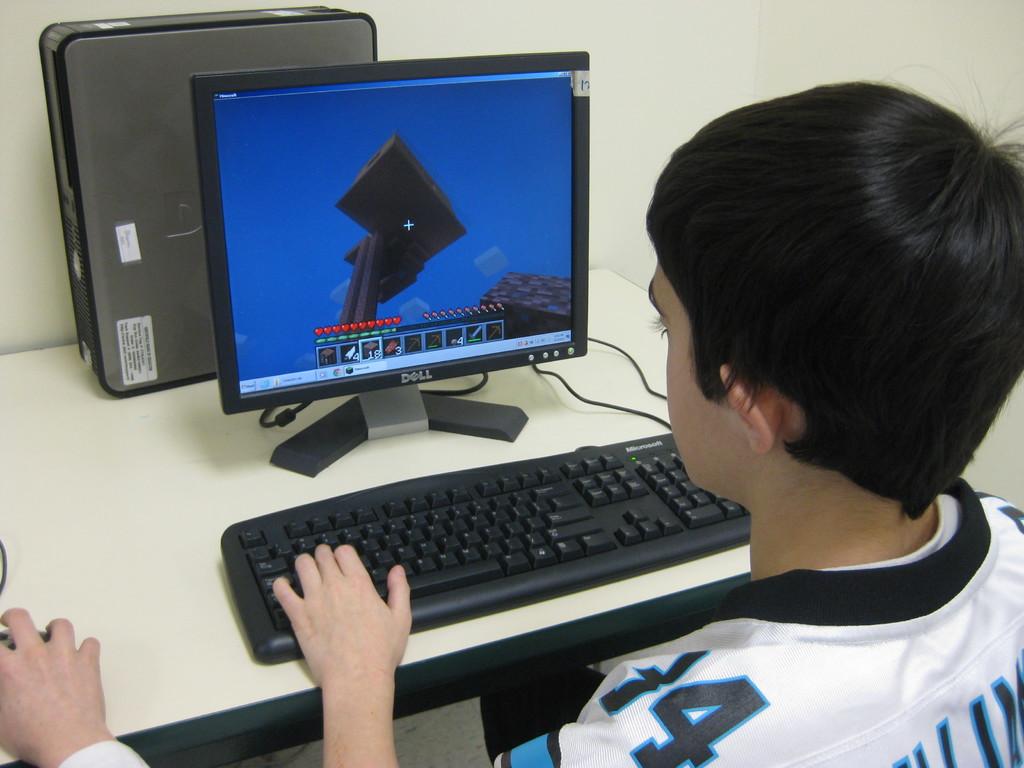What number is visible on the jersey sleeve?
Keep it short and to the point. 4. Who manufactured the monitor?
Provide a succinct answer. Dell. 